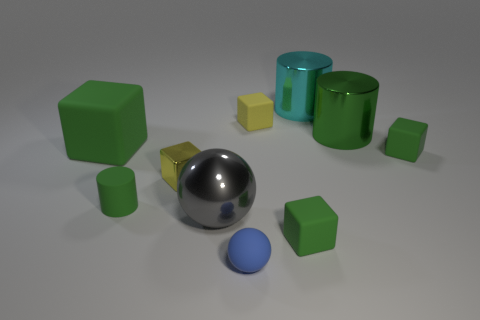What is the size of the matte sphere?
Provide a short and direct response. Small. What is the size of the cylinder that is behind the metal object right of the big cyan object?
Make the answer very short. Large. There is a large green thing that is the same shape as the tiny yellow rubber thing; what material is it?
Give a very brief answer. Rubber. How many large shiny things are there?
Give a very brief answer. 3. The large thing that is in front of the tiny green rubber object that is on the right side of the big shiny thing behind the yellow rubber object is what color?
Keep it short and to the point. Gray. Are there fewer blue matte cylinders than blue rubber things?
Ensure brevity in your answer.  Yes. There is a small rubber object that is the same shape as the large gray object; what is its color?
Your response must be concise. Blue. What color is the large ball that is the same material as the large cyan object?
Ensure brevity in your answer.  Gray. How many green balls have the same size as the yellow matte block?
Your response must be concise. 0. What is the blue thing made of?
Your answer should be compact. Rubber. 